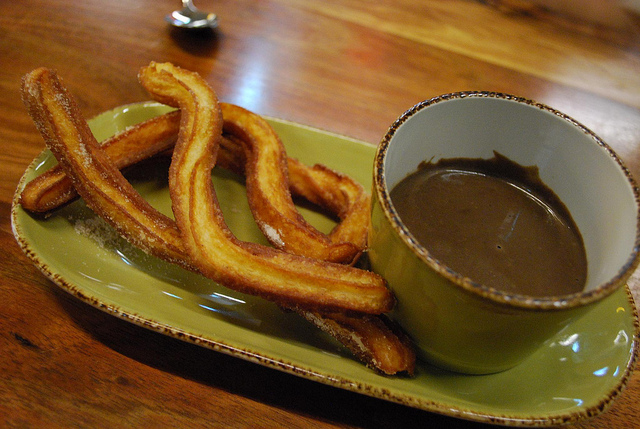What color is in the mug? The inside of the mug is green, consistent with the color of the plate. The beverage inside appears to be dark brown chocolate. 